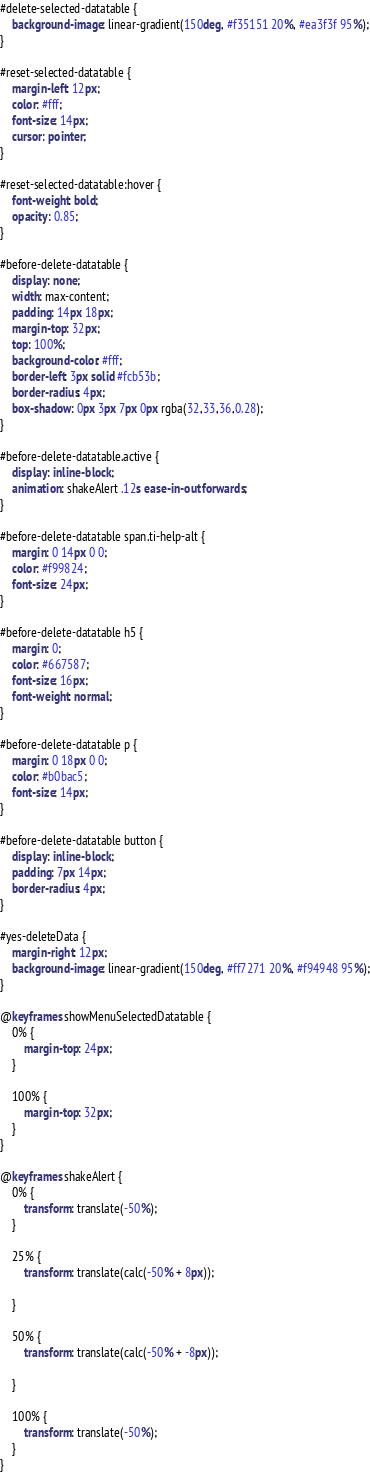Convert code to text. <code><loc_0><loc_0><loc_500><loc_500><_CSS_>
#delete-selected-datatable {
    background-image: linear-gradient(150deg, #f35151 20%, #ea3f3f 95%);
}

#reset-selected-datatable {
    margin-left: 12px;
    color: #fff;
    font-size: 14px;
    cursor: pointer;
}

#reset-selected-datatable:hover {
    font-weight: bold;
    opacity: 0.85;
}

#before-delete-datatable {
    display: none;
    width: max-content;
    padding: 14px 18px;
    margin-top: 32px;
    top: 100%;
    background-color: #fff;
    border-left: 3px solid #fcb53b;
    border-radius: 4px;
    box-shadow: 0px 3px 7px 0px rgba(32,33,36,0.28);
}

#before-delete-datatable.active {
    display: inline-block;
    animation: shakeAlert .12s ease-in-out forwards;
}

#before-delete-datatable span.ti-help-alt {
    margin: 0 14px 0 0;
    color: #f99824;
    font-size: 24px;
}

#before-delete-datatable h5 {
    margin: 0;
    color: #667587;
    font-size: 16px;
    font-weight: normal;
}

#before-delete-datatable p {
    margin: 0 18px 0 0;
    color: #b0bac5;
    font-size: 14px;
}

#before-delete-datatable button {
    display: inline-block;
    padding: 7px 14px;
    border-radius: 4px;
}

#yes-deleteData {
    margin-right: 12px;
    background-image: linear-gradient(150deg, #ff7271 20%, #f94948 95%);
}

@keyframes showMenuSelectedDatatable {
    0% {
        margin-top: 24px;
    }
    
    100% {
        margin-top: 32px;
    }
}

@keyframes shakeAlert {
    0% {
        transform: translate(-50%);
    }

    25% {
        transform: translate(calc(-50% + 8px));

    }

    50% {
        transform: translate(calc(-50% + -8px));

    }

    100% {
        transform: translate(-50%);
    }
}</code> 